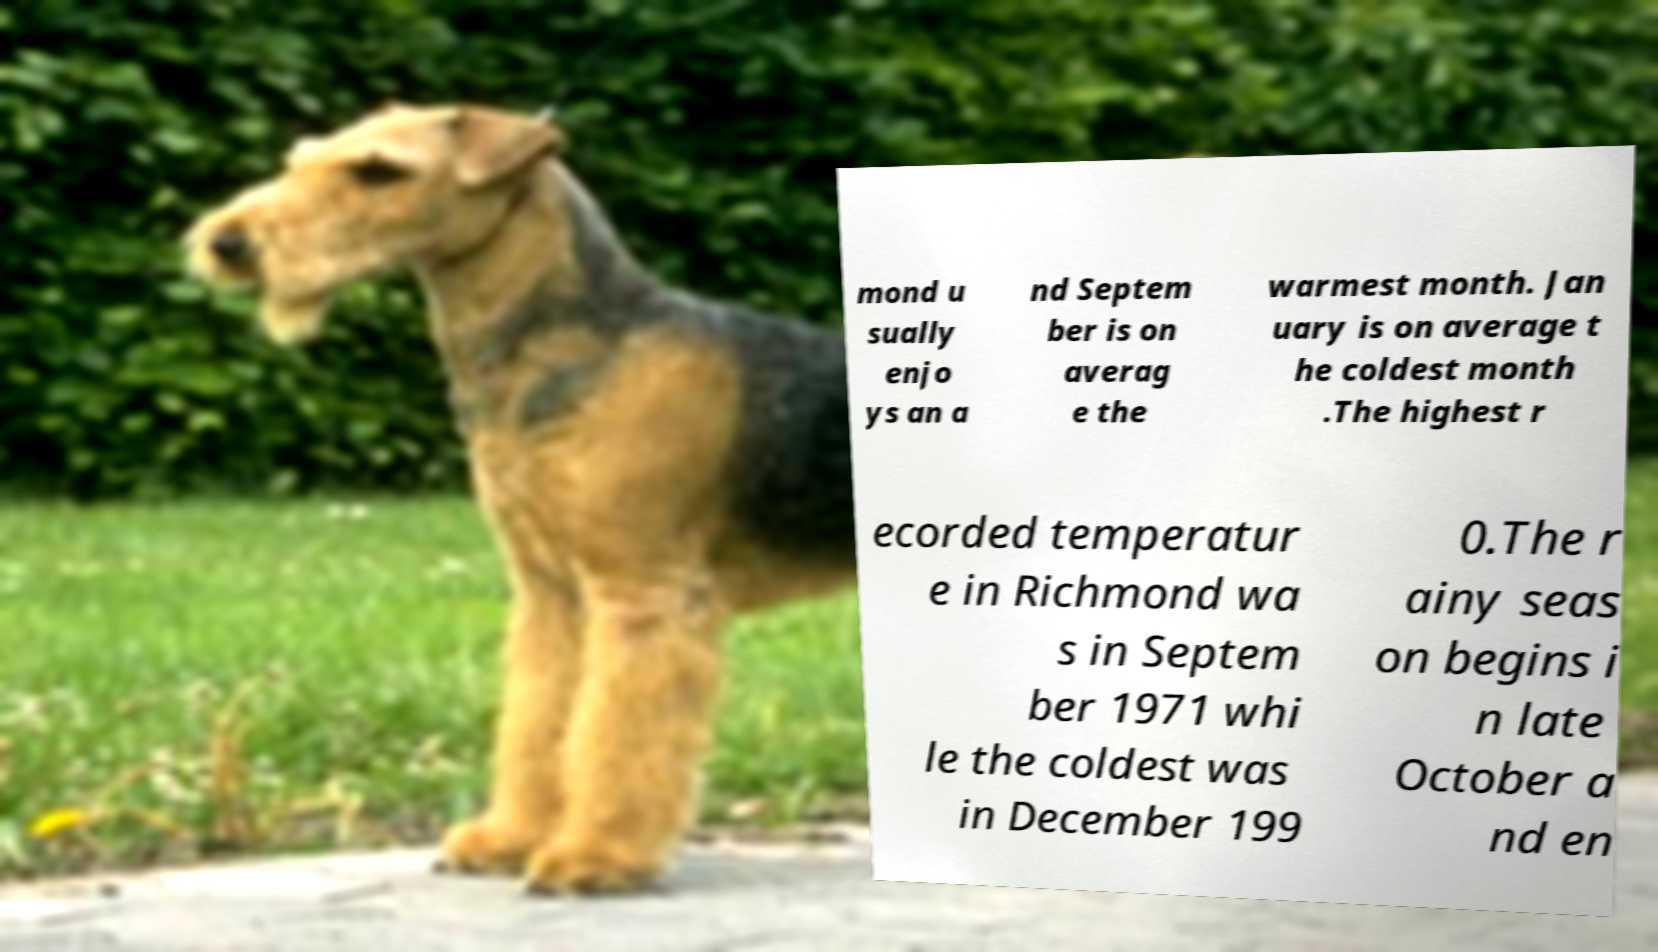Can you accurately transcribe the text from the provided image for me? mond u sually enjo ys an a nd Septem ber is on averag e the warmest month. Jan uary is on average t he coldest month .The highest r ecorded temperatur e in Richmond wa s in Septem ber 1971 whi le the coldest was in December 199 0.The r ainy seas on begins i n late October a nd en 